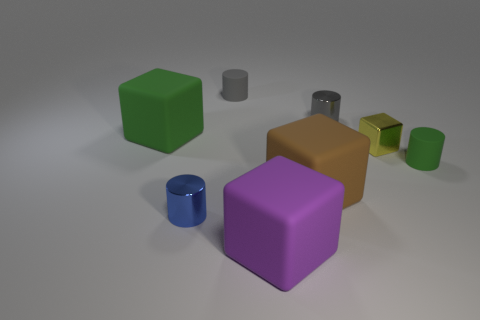There is a thing that is in front of the blue metal object; is it the same shape as the tiny yellow thing?
Your response must be concise. Yes. The cylinder that is the same material as the tiny blue object is what color?
Provide a short and direct response. Gray. Are there any large cubes behind the shiny thing that is on the left side of the shiny thing behind the green cube?
Your response must be concise. Yes. What is the shape of the small gray metallic object?
Offer a very short reply. Cylinder. Is the number of tiny yellow metal cubes that are to the right of the tiny cube less than the number of big brown matte spheres?
Give a very brief answer. No. Is there a gray rubber object that has the same shape as the small green matte thing?
Offer a terse response. Yes. What shape is the blue shiny thing that is the same size as the green matte cylinder?
Keep it short and to the point. Cylinder. What number of things are large red metallic cylinders or small blue shiny objects?
Your response must be concise. 1. Are any big cyan matte cylinders visible?
Make the answer very short. No. Is the number of brown blocks less than the number of metallic cylinders?
Provide a succinct answer. Yes. 